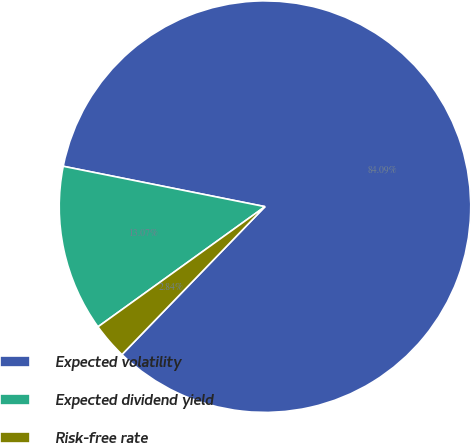Convert chart to OTSL. <chart><loc_0><loc_0><loc_500><loc_500><pie_chart><fcel>Expected volatility<fcel>Expected dividend yield<fcel>Risk-free rate<nl><fcel>84.09%<fcel>13.07%<fcel>2.84%<nl></chart> 